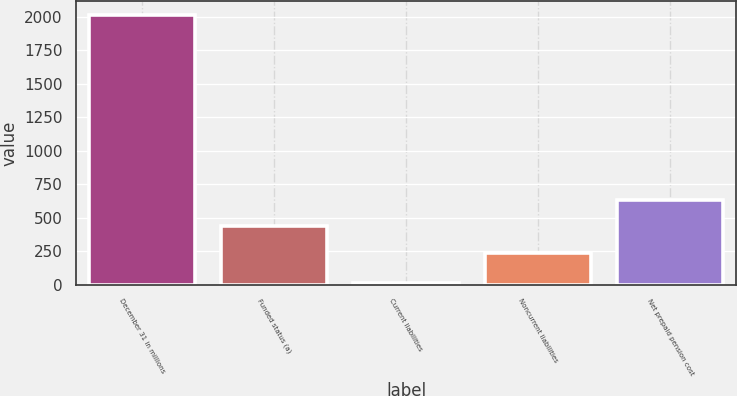Convert chart to OTSL. <chart><loc_0><loc_0><loc_500><loc_500><bar_chart><fcel>December 31 in millions<fcel>Funded status (a)<fcel>Current liabilities<fcel>Noncurrent liabilities<fcel>Net prepaid pension cost<nl><fcel>2014<fcel>435<fcel>14<fcel>235<fcel>635<nl></chart> 